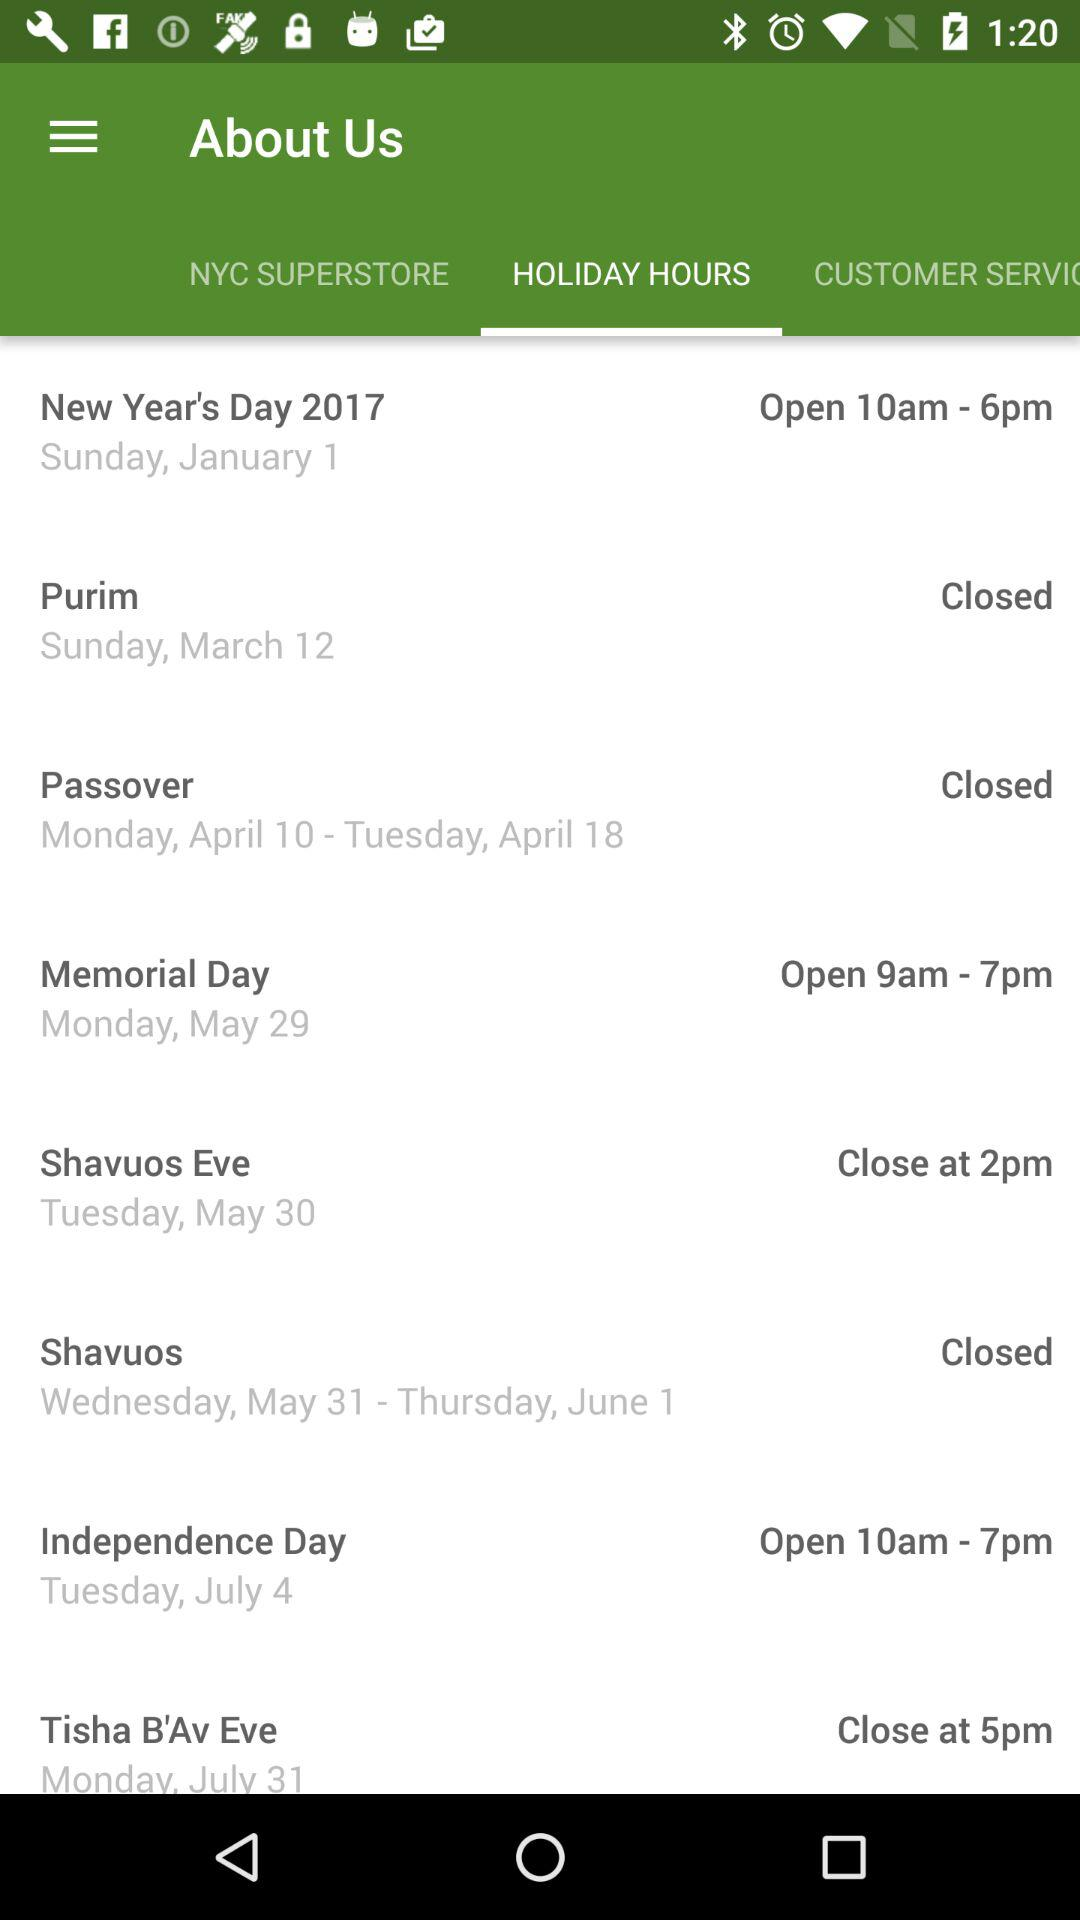What is the closing time on 30 May 2017? The closing time on 30 May 2017 is 2 p.m. 